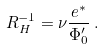Convert formula to latex. <formula><loc_0><loc_0><loc_500><loc_500>R _ { H } ^ { - 1 } = \nu \frac { e ^ { * } } { \Phi _ { 0 } ^ { \prime } } \, .</formula> 